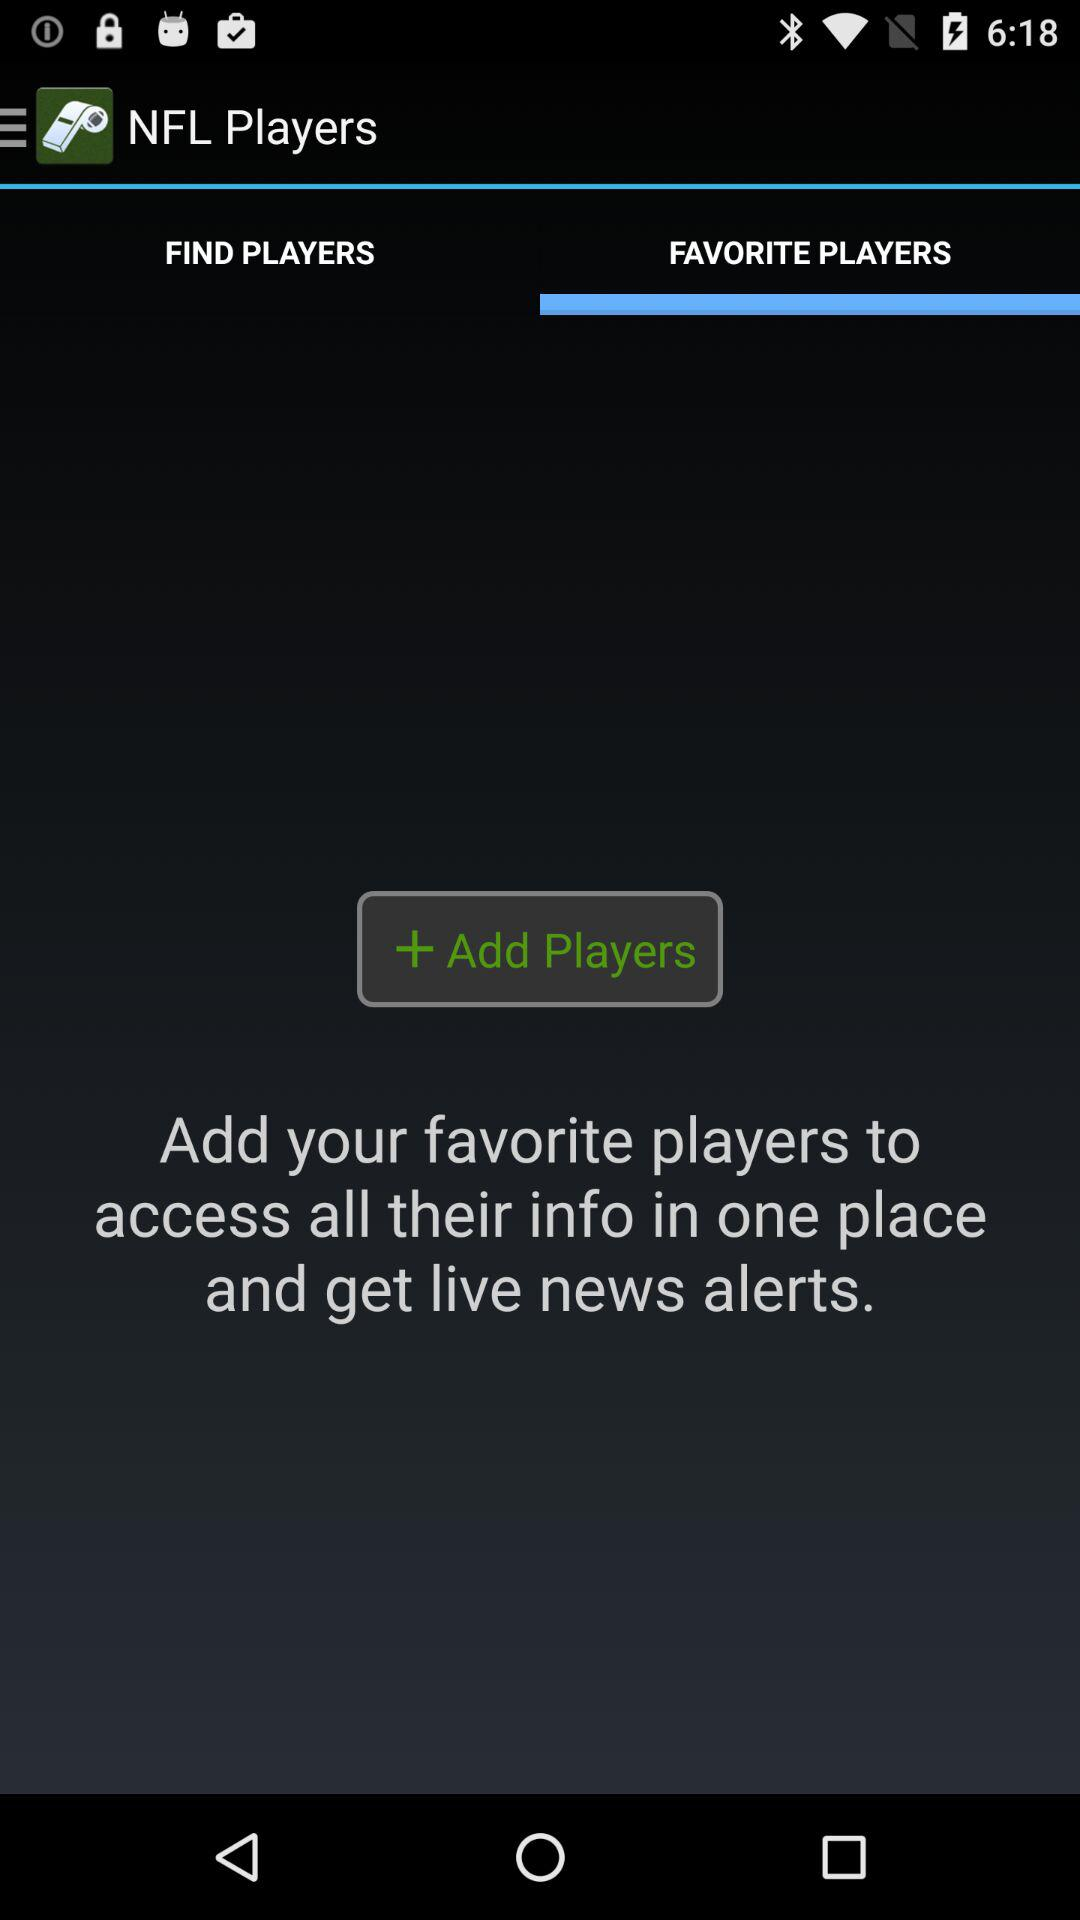Which tab is open? The open tab is "FAVORITE PLAYERS". 